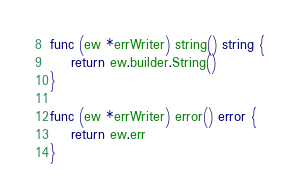<code> <loc_0><loc_0><loc_500><loc_500><_Go_>
func (ew *errWriter) string() string {
	return ew.builder.String()
}

func (ew *errWriter) error() error {
	return ew.err
}
</code> 